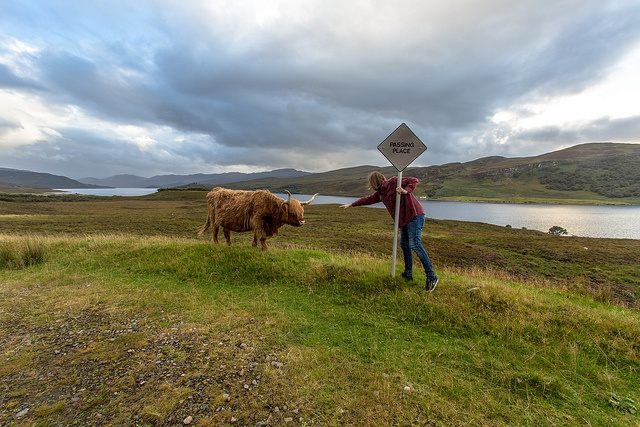Describe the objects in this image and their specific colors. I can see cow in lightblue, black, maroon, and gray tones and people in lightblue, black, maroon, navy, and blue tones in this image. 